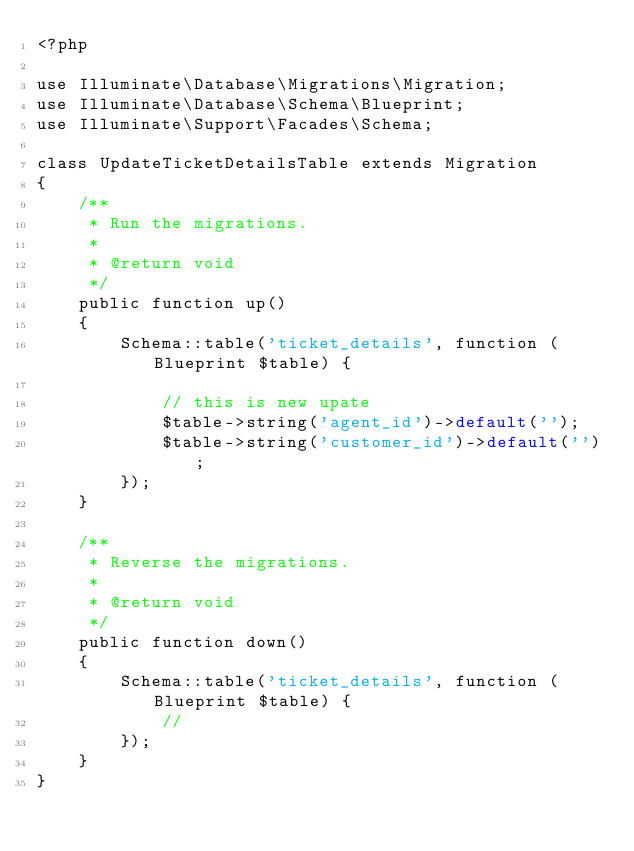Convert code to text. <code><loc_0><loc_0><loc_500><loc_500><_PHP_><?php

use Illuminate\Database\Migrations\Migration;
use Illuminate\Database\Schema\Blueprint;
use Illuminate\Support\Facades\Schema;

class UpdateTicketDetailsTable extends Migration
{
    /**
     * Run the migrations.
     *
     * @return void
     */
    public function up()
    {
        Schema::table('ticket_details', function (Blueprint $table) {

            // this is new upate
            $table->string('agent_id')->default('');
            $table->string('customer_id')->default('');
        });
    }

    /**
     * Reverse the migrations.
     *
     * @return void
     */
    public function down()
    {
        Schema::table('ticket_details', function (Blueprint $table) {
            //
        });
    }
}
</code> 